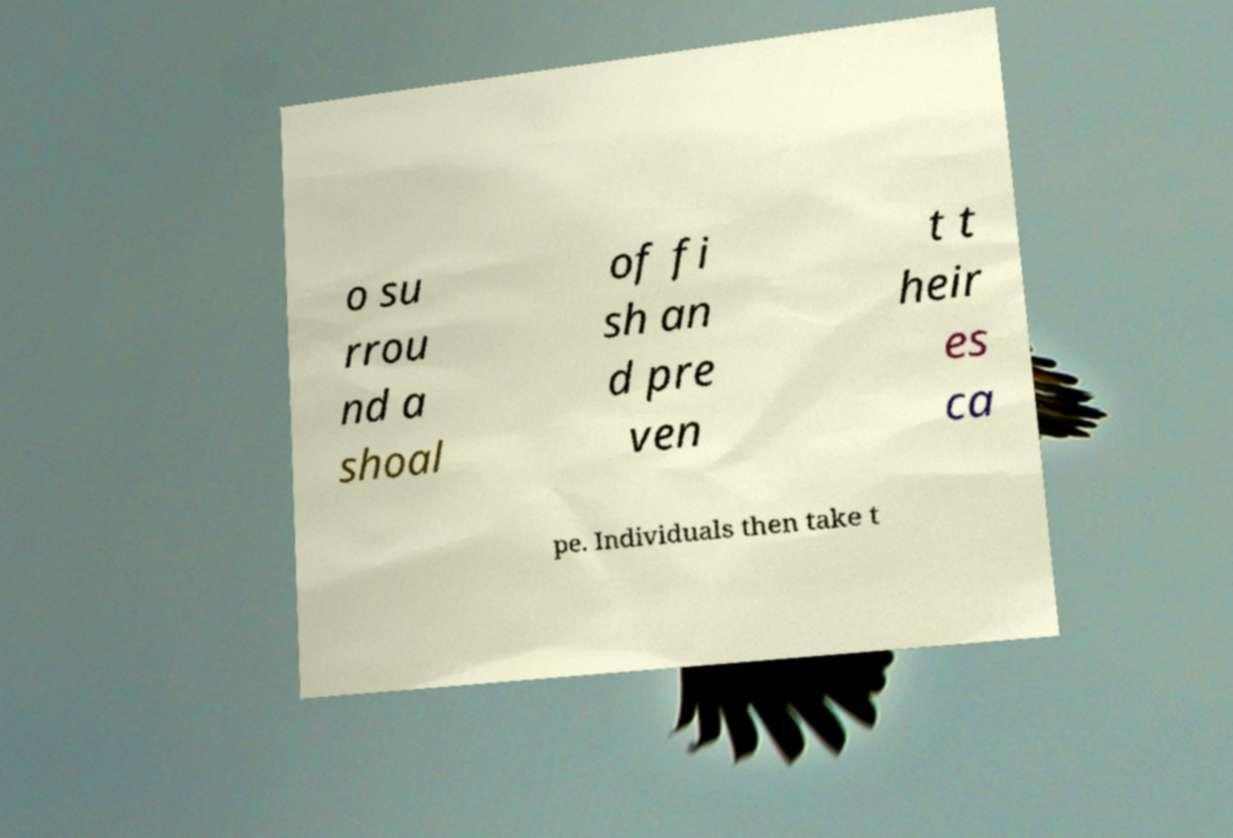Please identify and transcribe the text found in this image. o su rrou nd a shoal of fi sh an d pre ven t t heir es ca pe. Individuals then take t 